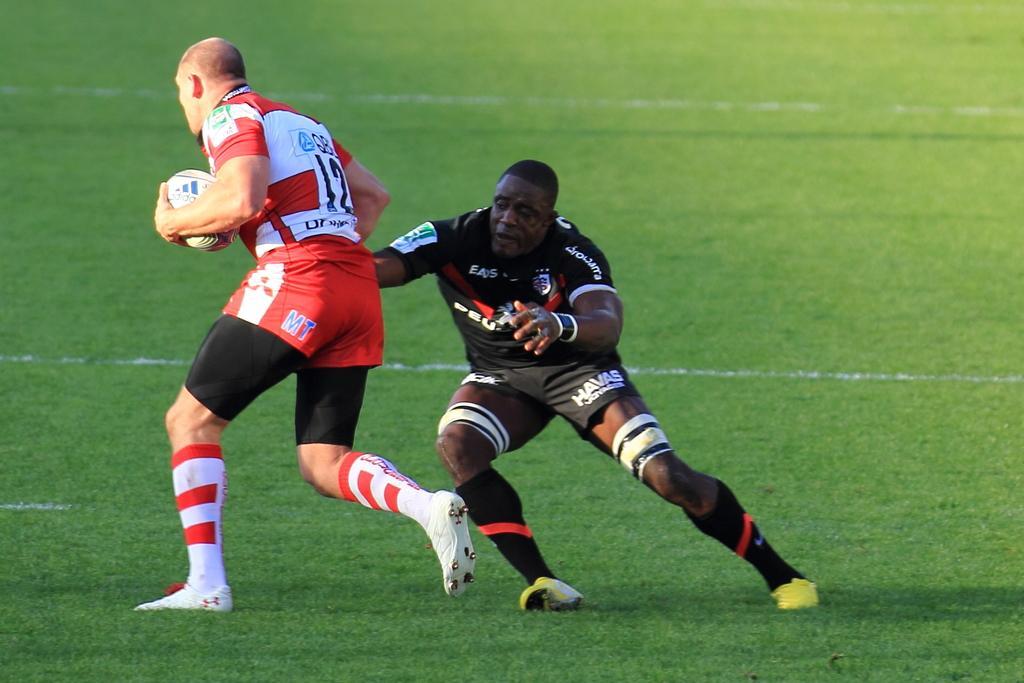How would you summarize this image in a sentence or two? On the ground there are two persons. To the left side there is a man with red t-shirt is running by holding a ball in his hand. Behind him there is another man with black t-shirt is running behind him. 